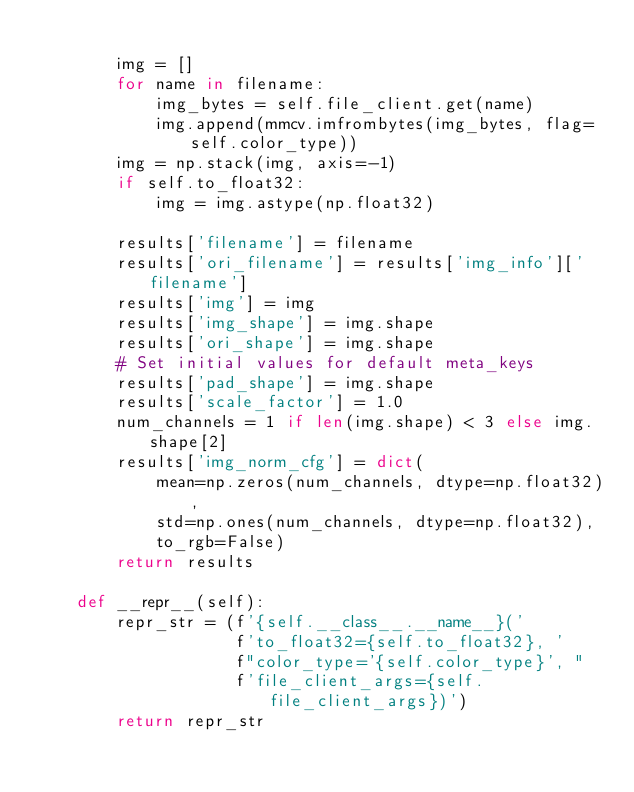<code> <loc_0><loc_0><loc_500><loc_500><_Python_>
        img = []
        for name in filename:
            img_bytes = self.file_client.get(name)
            img.append(mmcv.imfrombytes(img_bytes, flag=self.color_type))
        img = np.stack(img, axis=-1)
        if self.to_float32:
            img = img.astype(np.float32)

        results['filename'] = filename
        results['ori_filename'] = results['img_info']['filename']
        results['img'] = img
        results['img_shape'] = img.shape
        results['ori_shape'] = img.shape
        # Set initial values for default meta_keys
        results['pad_shape'] = img.shape
        results['scale_factor'] = 1.0
        num_channels = 1 if len(img.shape) < 3 else img.shape[2]
        results['img_norm_cfg'] = dict(
            mean=np.zeros(num_channels, dtype=np.float32),
            std=np.ones(num_channels, dtype=np.float32),
            to_rgb=False)
        return results

    def __repr__(self):
        repr_str = (f'{self.__class__.__name__}('
                    f'to_float32={self.to_float32}, '
                    f"color_type='{self.color_type}', "
                    f'file_client_args={self.file_client_args})')
        return repr_str

</code> 